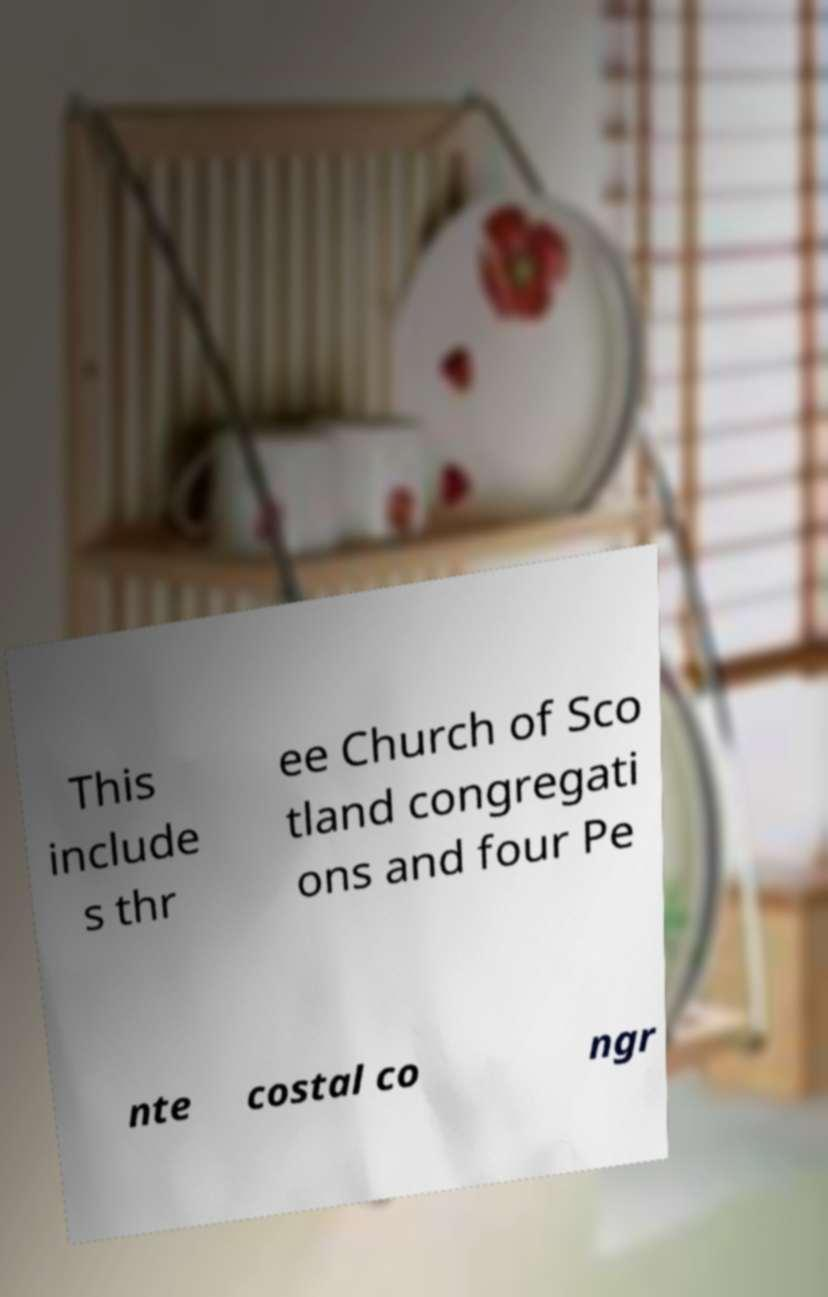Could you extract and type out the text from this image? This include s thr ee Church of Sco tland congregati ons and four Pe nte costal co ngr 